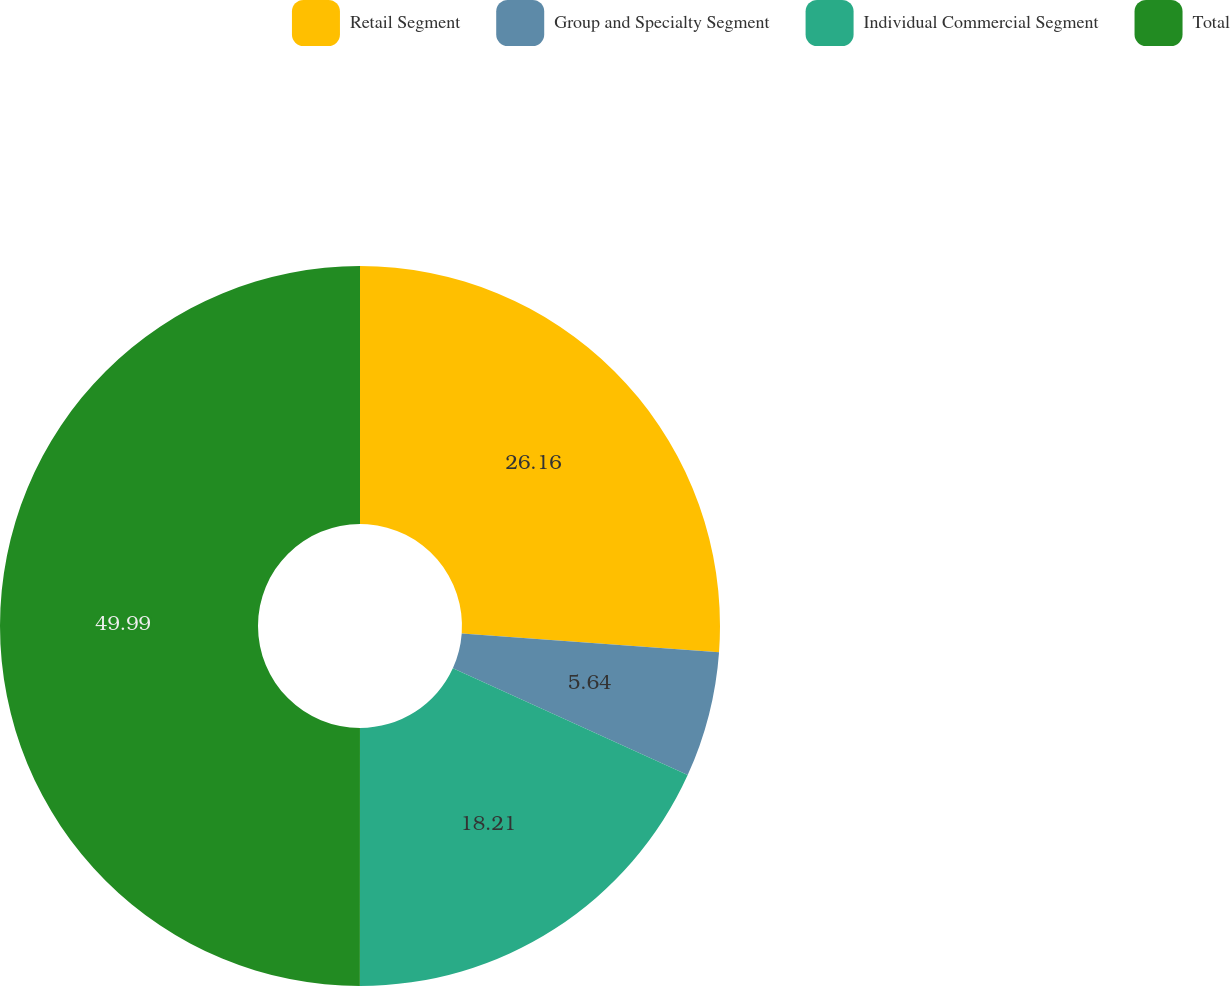<chart> <loc_0><loc_0><loc_500><loc_500><pie_chart><fcel>Retail Segment<fcel>Group and Specialty Segment<fcel>Individual Commercial Segment<fcel>Total<nl><fcel>26.16%<fcel>5.64%<fcel>18.21%<fcel>50.0%<nl></chart> 